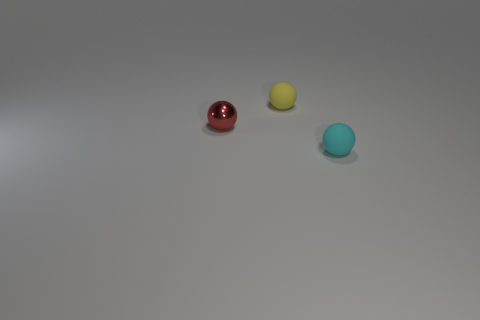There is a metallic object that is the same shape as the cyan matte object; what color is it?
Provide a short and direct response. Red. How big is the thing that is both to the right of the small red sphere and in front of the tiny yellow thing?
Provide a succinct answer. Small. There is a small object that is both on the right side of the red shiny thing and in front of the tiny yellow thing; what shape is it?
Keep it short and to the point. Sphere. Is there anything else that is made of the same material as the red object?
Ensure brevity in your answer.  No. What color is the other rubber sphere that is the same size as the cyan sphere?
Offer a terse response. Yellow. There is a rubber thing that is behind the small rubber sphere that is on the right side of the small sphere behind the red metallic ball; what is its color?
Keep it short and to the point. Yellow. Do the red metallic object and the small yellow object have the same shape?
Offer a terse response. Yes. What color is the thing that is made of the same material as the tiny yellow ball?
Your answer should be very brief. Cyan. How many things are rubber objects that are in front of the small red shiny thing or cyan rubber things?
Provide a succinct answer. 1. How big is the matte sphere behind the red ball?
Your response must be concise. Small. 